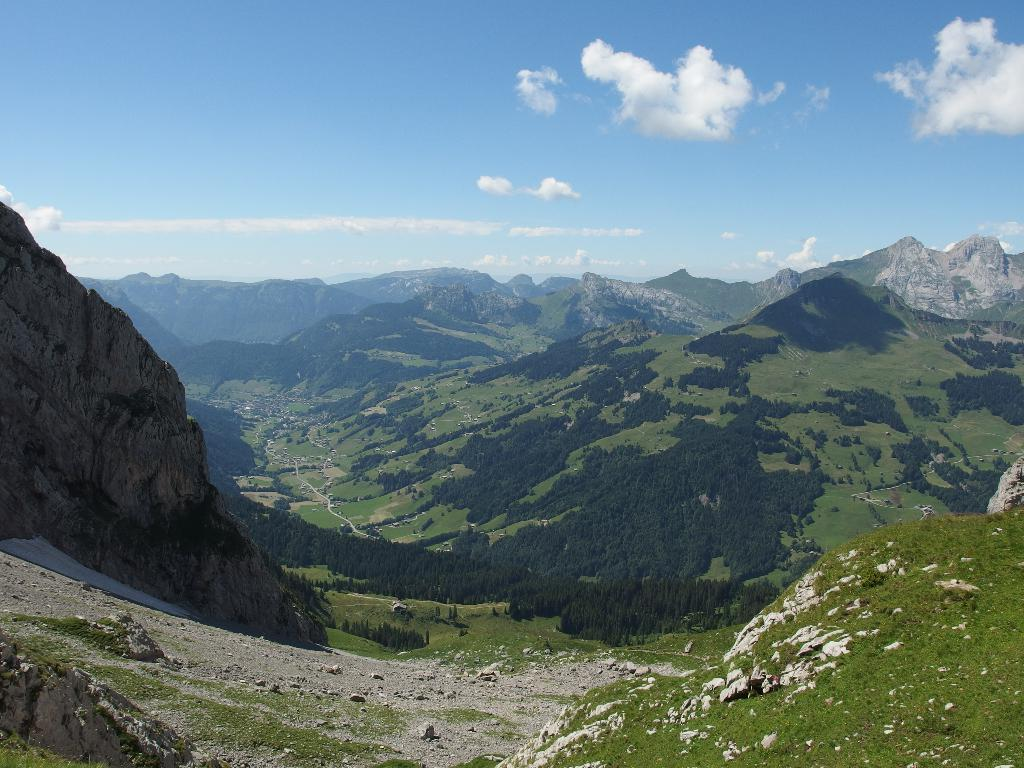What type of landscape is depicted in the image? The image contains hills. What can be seen growing in the image? There is greenery in the image. What objects are present in the foreground of the image? Stones are present in the foreground of the image. What is visible in the background of the image? The sky is visible in the background of the image. What type of food is being prepared on the sticks in the image? There is no food or sticks present in the image; it contains hills, greenery, stones, and the sky. 